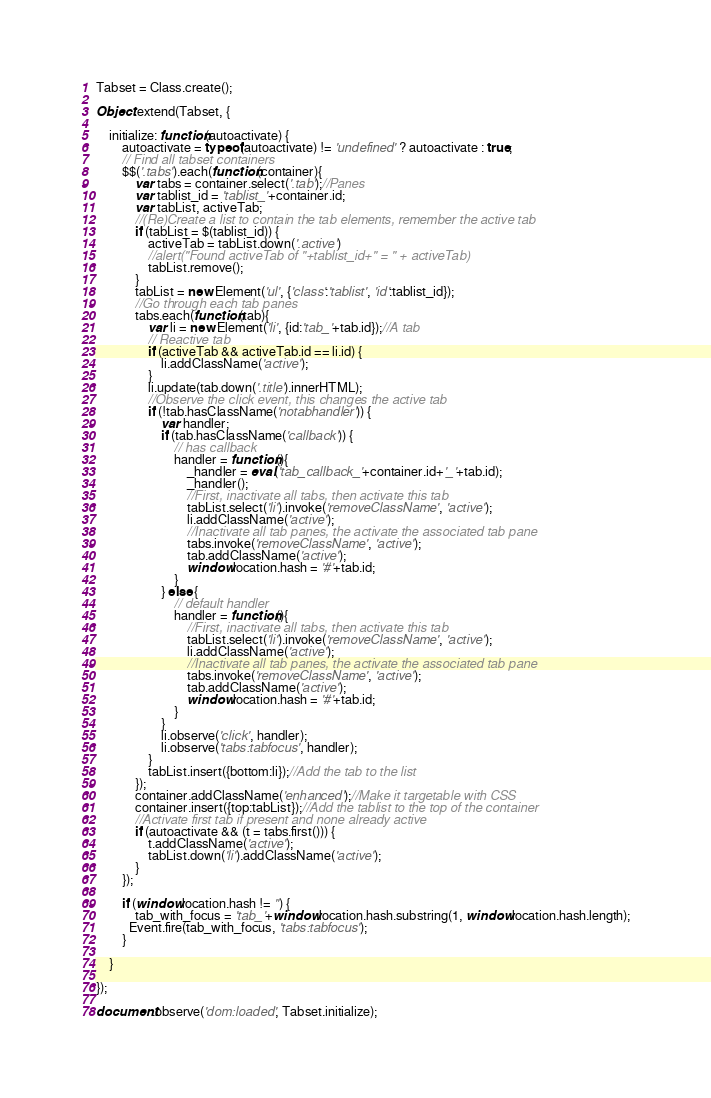Convert code to text. <code><loc_0><loc_0><loc_500><loc_500><_JavaScript_>
Tabset = Class.create();

Object.extend(Tabset, {

	initialize: function(autoactivate) {
		autoactivate = typeof(autoactivate) != 'undefined' ? autoactivate : true;
		// Find all tabset containers
		$$('.tabs').each(function(container){
			var tabs = container.select('.tab');//Panes
			var tablist_id = 'tablist_'+container.id;	
			var tabList, activeTab;
			//(Re)Create a list to contain the tab elements, remember the active tab
			if (tabList = $(tablist_id)) { 
				activeTab = tabList.down('.active')
				//alert("Found activeTab of "+tablist_id+" = " + activeTab)
				tabList.remove(); 
			}
			tabList = new Element('ul', {'class':'tablist', 'id':tablist_id});
			//Go through each tab panes
			tabs.each(function(tab){
				var li = new Element('li', {id:'tab_'+tab.id});//A tab
				// Reactive tab
				if (activeTab && activeTab.id == li.id) {
					li.addClassName('active');
				}
				li.update(tab.down('.title').innerHTML);
				//Observe the click event, this changes the active tab
				if (!tab.hasClassName('notabhandler')) {
					var handler;
					if (tab.hasClassName('callback')) {
						// has callback
						handler = function(){
							_handler = eval('tab_callback_'+container.id+'_'+tab.id);
							_handler();					
							//First, inactivate all tabs, then activate this tab
							tabList.select('li').invoke('removeClassName', 'active');
							li.addClassName('active');
							//Inactivate all tab panes, the activate the associated tab pane
							tabs.invoke('removeClassName', 'active');
							tab.addClassName('active');
							window.location.hash = '#'+tab.id;
						}
					} else {
						// default handler
						handler = function(){
							//First, inactivate all tabs, then activate this tab
							tabList.select('li').invoke('removeClassName', 'active');
							li.addClassName('active');
							//Inactivate all tab panes, the activate the associated tab pane
							tabs.invoke('removeClassName', 'active');
							tab.addClassName('active');
							window.location.hash = '#'+tab.id;
						}
					}
					li.observe('click', handler);
					li.observe('tabs:tabfocus', handler);
				}
				tabList.insert({bottom:li});//Add the tab to the list
			});
			container.addClassName('enhanced');//Make it targetable with CSS
			container.insert({top:tabList});//Add the tablist to the top of the container
			//Activate first tab if present and none already active
			if (autoactivate && (t = tabs.first())) {
				t.addClassName('active');
				tabList.down('li').addClassName('active');
			}    
		});

		if (window.location.hash != '') {
			tab_with_focus = 'tab_'+window.location.hash.substring(1, window.location.hash.length);
		  Event.fire(tab_with_focus, 'tabs:tabfocus'); 
		}

	}

});

document.observe('dom:loaded', Tabset.initialize);</code> 